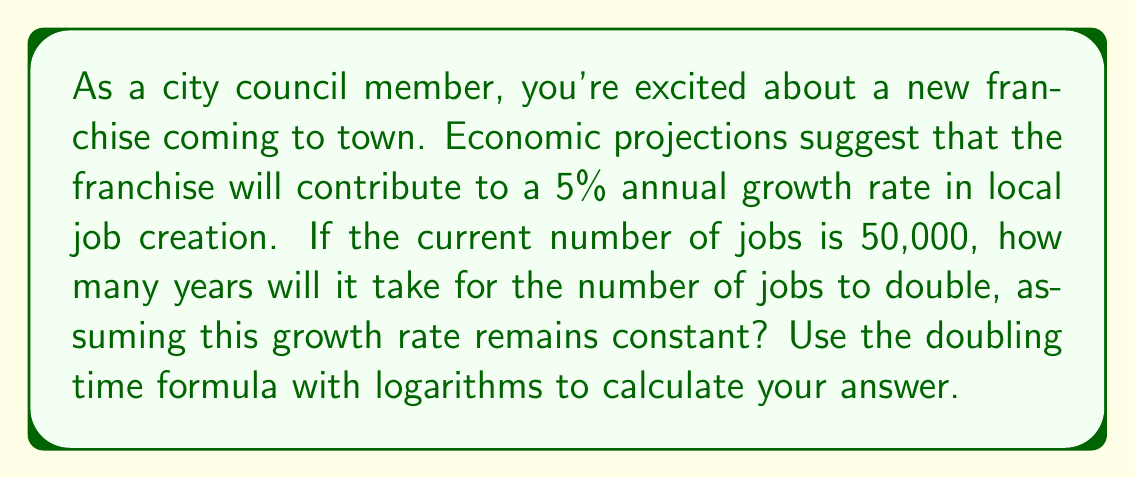Provide a solution to this math problem. To solve this problem, we'll use the doubling time formula:

$$ T = \frac{\ln(2)}{\ln(1 + r)} $$

Where:
$T$ is the time it takes for the quantity to double
$r$ is the growth rate as a decimal

Step 1: Convert the growth rate to a decimal
$r = 5\% = 0.05$

Step 2: Plug the values into the formula
$$ T = \frac{\ln(2)}{\ln(1 + 0.05)} $$

Step 3: Calculate the natural logarithms
$$ T = \frac{0.6931471805599453}{0.04879016416603439} $$

Step 4: Divide
$$ T \approx 14.2067 $$

Step 5: Round to the nearest whole number of years

The doubling time is approximately 14 years.

Note: This calculation doesn't depend on the initial number of jobs (50,000) because we're using the doubling time formula, which only considers the growth rate.
Answer: 14 years 